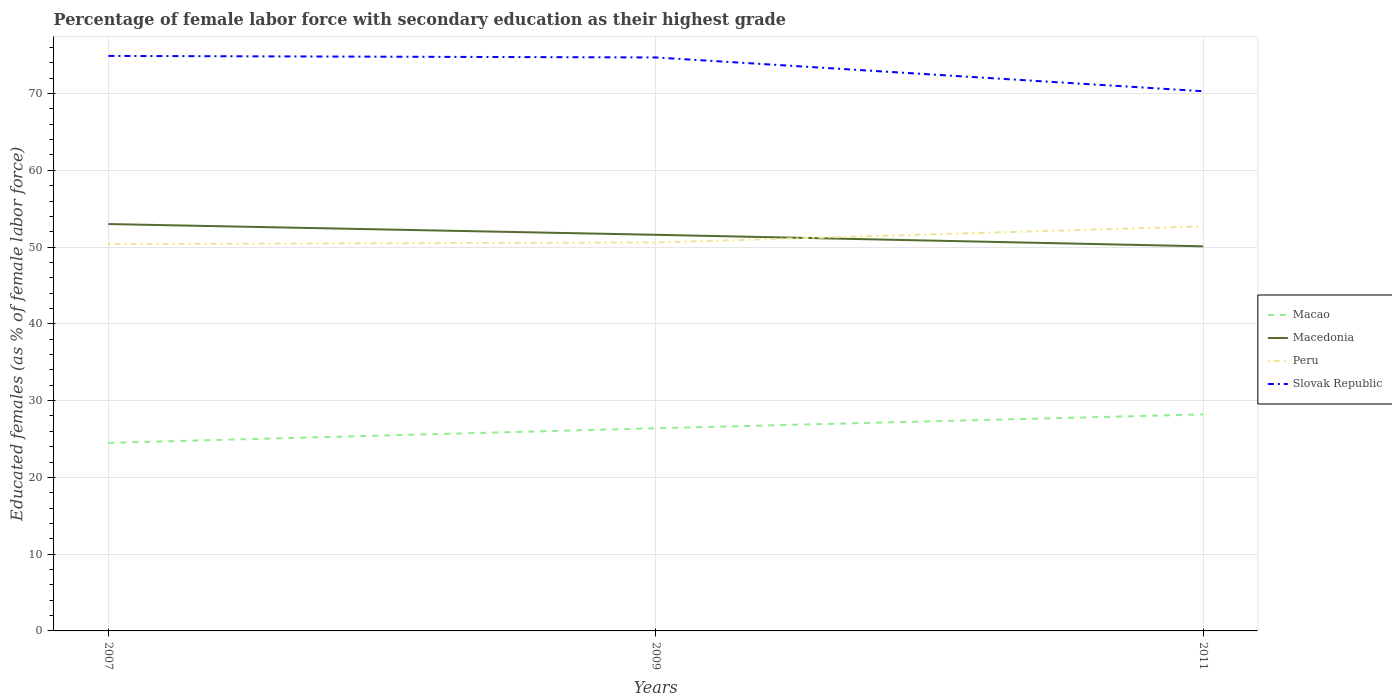How many different coloured lines are there?
Keep it short and to the point. 4. Does the line corresponding to Macao intersect with the line corresponding to Slovak Republic?
Provide a short and direct response. No. Across all years, what is the maximum percentage of female labor force with secondary education in Slovak Republic?
Offer a terse response. 70.3. In which year was the percentage of female labor force with secondary education in Peru maximum?
Keep it short and to the point. 2007. What is the total percentage of female labor force with secondary education in Slovak Republic in the graph?
Keep it short and to the point. 0.2. What is the difference between the highest and the second highest percentage of female labor force with secondary education in Macedonia?
Make the answer very short. 2.9. What is the difference between the highest and the lowest percentage of female labor force with secondary education in Macao?
Your response must be concise. 2. How many lines are there?
Give a very brief answer. 4. How many years are there in the graph?
Make the answer very short. 3. What is the difference between two consecutive major ticks on the Y-axis?
Provide a short and direct response. 10. Are the values on the major ticks of Y-axis written in scientific E-notation?
Offer a terse response. No. Does the graph contain any zero values?
Make the answer very short. No. Where does the legend appear in the graph?
Offer a very short reply. Center right. How many legend labels are there?
Offer a terse response. 4. How are the legend labels stacked?
Your answer should be very brief. Vertical. What is the title of the graph?
Provide a short and direct response. Percentage of female labor force with secondary education as their highest grade. Does "Egypt, Arab Rep." appear as one of the legend labels in the graph?
Give a very brief answer. No. What is the label or title of the X-axis?
Provide a succinct answer. Years. What is the label or title of the Y-axis?
Provide a succinct answer. Educated females (as % of female labor force). What is the Educated females (as % of female labor force) in Peru in 2007?
Ensure brevity in your answer.  50.4. What is the Educated females (as % of female labor force) of Slovak Republic in 2007?
Your response must be concise. 74.9. What is the Educated females (as % of female labor force) in Macao in 2009?
Keep it short and to the point. 26.4. What is the Educated females (as % of female labor force) of Macedonia in 2009?
Make the answer very short. 51.6. What is the Educated females (as % of female labor force) in Peru in 2009?
Give a very brief answer. 50.6. What is the Educated females (as % of female labor force) in Slovak Republic in 2009?
Offer a very short reply. 74.7. What is the Educated females (as % of female labor force) in Macao in 2011?
Make the answer very short. 28.2. What is the Educated females (as % of female labor force) in Macedonia in 2011?
Make the answer very short. 50.1. What is the Educated females (as % of female labor force) in Peru in 2011?
Give a very brief answer. 52.7. What is the Educated females (as % of female labor force) in Slovak Republic in 2011?
Keep it short and to the point. 70.3. Across all years, what is the maximum Educated females (as % of female labor force) in Macao?
Your response must be concise. 28.2. Across all years, what is the maximum Educated females (as % of female labor force) in Peru?
Provide a short and direct response. 52.7. Across all years, what is the maximum Educated females (as % of female labor force) of Slovak Republic?
Ensure brevity in your answer.  74.9. Across all years, what is the minimum Educated females (as % of female labor force) of Macao?
Provide a short and direct response. 24.5. Across all years, what is the minimum Educated females (as % of female labor force) of Macedonia?
Keep it short and to the point. 50.1. Across all years, what is the minimum Educated females (as % of female labor force) of Peru?
Your response must be concise. 50.4. Across all years, what is the minimum Educated females (as % of female labor force) in Slovak Republic?
Your answer should be very brief. 70.3. What is the total Educated females (as % of female labor force) in Macao in the graph?
Provide a succinct answer. 79.1. What is the total Educated females (as % of female labor force) in Macedonia in the graph?
Keep it short and to the point. 154.7. What is the total Educated females (as % of female labor force) in Peru in the graph?
Give a very brief answer. 153.7. What is the total Educated females (as % of female labor force) in Slovak Republic in the graph?
Make the answer very short. 219.9. What is the difference between the Educated females (as % of female labor force) in Macedonia in 2007 and that in 2009?
Keep it short and to the point. 1.4. What is the difference between the Educated females (as % of female labor force) of Peru in 2007 and that in 2009?
Provide a succinct answer. -0.2. What is the difference between the Educated females (as % of female labor force) in Slovak Republic in 2007 and that in 2009?
Provide a short and direct response. 0.2. What is the difference between the Educated females (as % of female labor force) of Slovak Republic in 2007 and that in 2011?
Keep it short and to the point. 4.6. What is the difference between the Educated females (as % of female labor force) in Slovak Republic in 2009 and that in 2011?
Your response must be concise. 4.4. What is the difference between the Educated females (as % of female labor force) in Macao in 2007 and the Educated females (as % of female labor force) in Macedonia in 2009?
Offer a very short reply. -27.1. What is the difference between the Educated females (as % of female labor force) in Macao in 2007 and the Educated females (as % of female labor force) in Peru in 2009?
Offer a very short reply. -26.1. What is the difference between the Educated females (as % of female labor force) of Macao in 2007 and the Educated females (as % of female labor force) of Slovak Republic in 2009?
Your answer should be compact. -50.2. What is the difference between the Educated females (as % of female labor force) of Macedonia in 2007 and the Educated females (as % of female labor force) of Peru in 2009?
Keep it short and to the point. 2.4. What is the difference between the Educated females (as % of female labor force) of Macedonia in 2007 and the Educated females (as % of female labor force) of Slovak Republic in 2009?
Offer a very short reply. -21.7. What is the difference between the Educated females (as % of female labor force) in Peru in 2007 and the Educated females (as % of female labor force) in Slovak Republic in 2009?
Make the answer very short. -24.3. What is the difference between the Educated females (as % of female labor force) of Macao in 2007 and the Educated females (as % of female labor force) of Macedonia in 2011?
Offer a terse response. -25.6. What is the difference between the Educated females (as % of female labor force) of Macao in 2007 and the Educated females (as % of female labor force) of Peru in 2011?
Give a very brief answer. -28.2. What is the difference between the Educated females (as % of female labor force) of Macao in 2007 and the Educated females (as % of female labor force) of Slovak Republic in 2011?
Ensure brevity in your answer.  -45.8. What is the difference between the Educated females (as % of female labor force) of Macedonia in 2007 and the Educated females (as % of female labor force) of Peru in 2011?
Make the answer very short. 0.3. What is the difference between the Educated females (as % of female labor force) in Macedonia in 2007 and the Educated females (as % of female labor force) in Slovak Republic in 2011?
Give a very brief answer. -17.3. What is the difference between the Educated females (as % of female labor force) in Peru in 2007 and the Educated females (as % of female labor force) in Slovak Republic in 2011?
Ensure brevity in your answer.  -19.9. What is the difference between the Educated females (as % of female labor force) of Macao in 2009 and the Educated females (as % of female labor force) of Macedonia in 2011?
Provide a succinct answer. -23.7. What is the difference between the Educated females (as % of female labor force) in Macao in 2009 and the Educated females (as % of female labor force) in Peru in 2011?
Give a very brief answer. -26.3. What is the difference between the Educated females (as % of female labor force) in Macao in 2009 and the Educated females (as % of female labor force) in Slovak Republic in 2011?
Your answer should be very brief. -43.9. What is the difference between the Educated females (as % of female labor force) of Macedonia in 2009 and the Educated females (as % of female labor force) of Slovak Republic in 2011?
Make the answer very short. -18.7. What is the difference between the Educated females (as % of female labor force) of Peru in 2009 and the Educated females (as % of female labor force) of Slovak Republic in 2011?
Provide a succinct answer. -19.7. What is the average Educated females (as % of female labor force) in Macao per year?
Your answer should be very brief. 26.37. What is the average Educated females (as % of female labor force) in Macedonia per year?
Give a very brief answer. 51.57. What is the average Educated females (as % of female labor force) in Peru per year?
Your response must be concise. 51.23. What is the average Educated females (as % of female labor force) of Slovak Republic per year?
Your answer should be compact. 73.3. In the year 2007, what is the difference between the Educated females (as % of female labor force) in Macao and Educated females (as % of female labor force) in Macedonia?
Provide a short and direct response. -28.5. In the year 2007, what is the difference between the Educated females (as % of female labor force) of Macao and Educated females (as % of female labor force) of Peru?
Your response must be concise. -25.9. In the year 2007, what is the difference between the Educated females (as % of female labor force) of Macao and Educated females (as % of female labor force) of Slovak Republic?
Provide a short and direct response. -50.4. In the year 2007, what is the difference between the Educated females (as % of female labor force) of Macedonia and Educated females (as % of female labor force) of Peru?
Your answer should be very brief. 2.6. In the year 2007, what is the difference between the Educated females (as % of female labor force) in Macedonia and Educated females (as % of female labor force) in Slovak Republic?
Keep it short and to the point. -21.9. In the year 2007, what is the difference between the Educated females (as % of female labor force) of Peru and Educated females (as % of female labor force) of Slovak Republic?
Give a very brief answer. -24.5. In the year 2009, what is the difference between the Educated females (as % of female labor force) in Macao and Educated females (as % of female labor force) in Macedonia?
Your answer should be compact. -25.2. In the year 2009, what is the difference between the Educated females (as % of female labor force) in Macao and Educated females (as % of female labor force) in Peru?
Offer a very short reply. -24.2. In the year 2009, what is the difference between the Educated females (as % of female labor force) of Macao and Educated females (as % of female labor force) of Slovak Republic?
Provide a succinct answer. -48.3. In the year 2009, what is the difference between the Educated females (as % of female labor force) in Macedonia and Educated females (as % of female labor force) in Slovak Republic?
Your answer should be compact. -23.1. In the year 2009, what is the difference between the Educated females (as % of female labor force) of Peru and Educated females (as % of female labor force) of Slovak Republic?
Keep it short and to the point. -24.1. In the year 2011, what is the difference between the Educated females (as % of female labor force) of Macao and Educated females (as % of female labor force) of Macedonia?
Offer a very short reply. -21.9. In the year 2011, what is the difference between the Educated females (as % of female labor force) in Macao and Educated females (as % of female labor force) in Peru?
Your answer should be compact. -24.5. In the year 2011, what is the difference between the Educated females (as % of female labor force) of Macao and Educated females (as % of female labor force) of Slovak Republic?
Make the answer very short. -42.1. In the year 2011, what is the difference between the Educated females (as % of female labor force) in Macedonia and Educated females (as % of female labor force) in Slovak Republic?
Make the answer very short. -20.2. In the year 2011, what is the difference between the Educated females (as % of female labor force) in Peru and Educated females (as % of female labor force) in Slovak Republic?
Provide a short and direct response. -17.6. What is the ratio of the Educated females (as % of female labor force) of Macao in 2007 to that in 2009?
Offer a very short reply. 0.93. What is the ratio of the Educated females (as % of female labor force) of Macedonia in 2007 to that in 2009?
Ensure brevity in your answer.  1.03. What is the ratio of the Educated females (as % of female labor force) in Peru in 2007 to that in 2009?
Provide a succinct answer. 1. What is the ratio of the Educated females (as % of female labor force) in Slovak Republic in 2007 to that in 2009?
Your answer should be compact. 1. What is the ratio of the Educated females (as % of female labor force) in Macao in 2007 to that in 2011?
Give a very brief answer. 0.87. What is the ratio of the Educated females (as % of female labor force) of Macedonia in 2007 to that in 2011?
Offer a very short reply. 1.06. What is the ratio of the Educated females (as % of female labor force) of Peru in 2007 to that in 2011?
Give a very brief answer. 0.96. What is the ratio of the Educated females (as % of female labor force) in Slovak Republic in 2007 to that in 2011?
Make the answer very short. 1.07. What is the ratio of the Educated females (as % of female labor force) in Macao in 2009 to that in 2011?
Make the answer very short. 0.94. What is the ratio of the Educated females (as % of female labor force) of Macedonia in 2009 to that in 2011?
Your answer should be compact. 1.03. What is the ratio of the Educated females (as % of female labor force) of Peru in 2009 to that in 2011?
Give a very brief answer. 0.96. What is the ratio of the Educated females (as % of female labor force) in Slovak Republic in 2009 to that in 2011?
Your response must be concise. 1.06. What is the difference between the highest and the second highest Educated females (as % of female labor force) in Macedonia?
Keep it short and to the point. 1.4. What is the difference between the highest and the lowest Educated females (as % of female labor force) of Macedonia?
Provide a short and direct response. 2.9. What is the difference between the highest and the lowest Educated females (as % of female labor force) of Slovak Republic?
Make the answer very short. 4.6. 